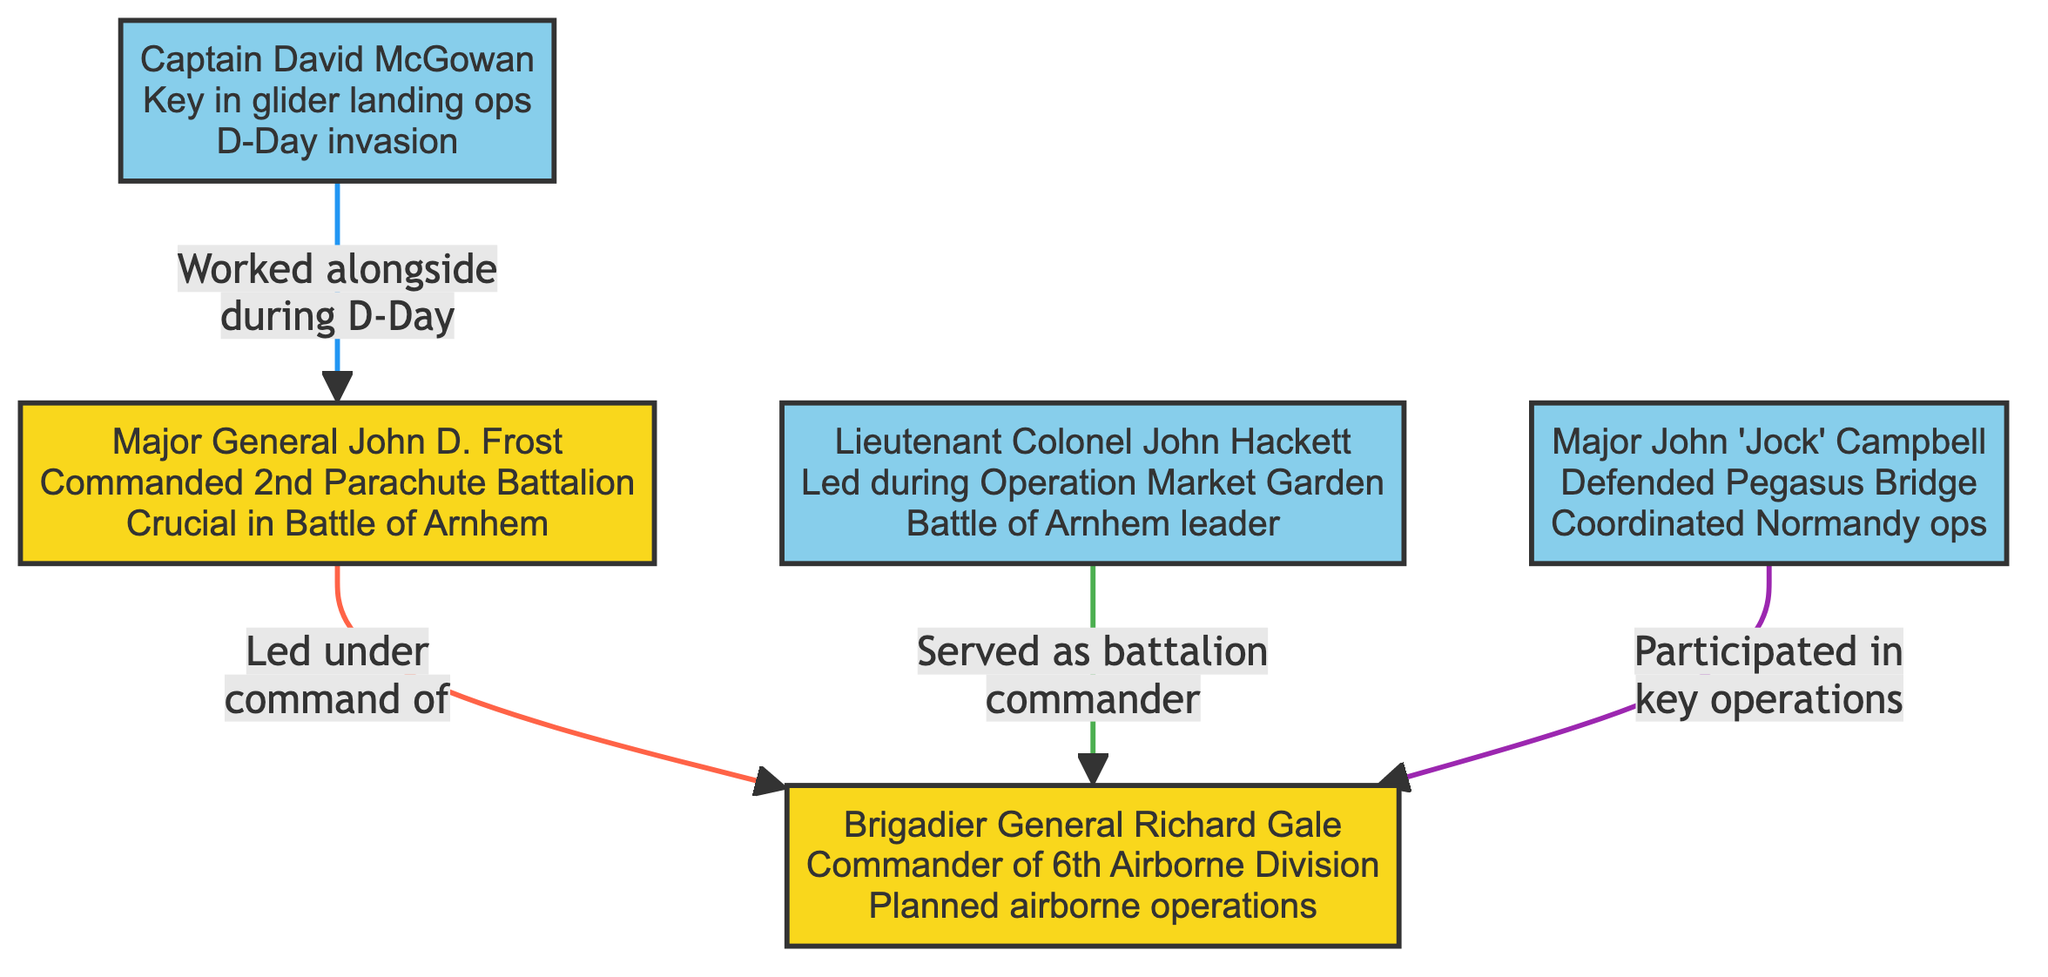What is the label of node 3? The label of node 3 is "Brigadier General Richard Gale." This can be found by looking at the description presented inside node 3 in the diagram.
Answer: Brigadier General Richard Gale How many nodes are present in the diagram? To determine the number of nodes, count each of the key figures represented. There are five key figures, so the total count is 5 nodes.
Answer: 5 Who did Major General John D. Frost work alongside during D-Day? According to the diagram, Major General John D. Frost worked alongside Captain David McGowan during D-Day, as indicated by the edge connecting these two nodes.
Answer: Captain David McGowan What relationship does Lieutenant Colonel John Hackett have with Brigadier General Richard Gale? The relationship indicated by the connection between these two nodes shows that Lieutenant Colonel John Hackett served as a battalion commander under Brigadier General Richard Gale.
Answer: Served as a battalion commander Which figure is described as the commander of the 6th Airborne Division? The diagram clearly marks Brigadier General Richard Gale as the commander of the 6th Airborne Division, highlighted in the corresponding node description.
Answer: Brigadier General Richard Gale What edge connects Major John 'Jock' Campbell to the commander? The edge representing Major John 'Jock' Campbell shows that he participated in key operations under Brigadier General Richard Gale, establishing the specific relationship between these figures in the graph.
Answer: Participated in key operations How many edges are present in the diagram? By counting the connections between the nodes in the diagram, there are four edges that describe relationships among the figures mentioned.
Answer: 4 What is the significance of the edge from Captain David McGowan to Major General John D. Frost? The edge signifies that Captain David McGowan worked alongside Major General John D. Frost during D-Day, representing collaboration during an important operation.
Answer: Worked alongside during D-Day 